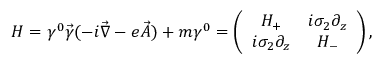<formula> <loc_0><loc_0><loc_500><loc_500>H = \gamma ^ { 0 } \vec { \gamma } ( - i \vec { \nabla } - e \vec { A } ) + m \gamma ^ { 0 } = \left ( \begin{array} { c c } { { H _ { + } } } & { { i \sigma _ { 2 } \partial _ { z } } } \\ { { i \sigma _ { 2 } \partial _ { z } } } & { { H _ { - } } } \end{array} \right ) ,</formula> 